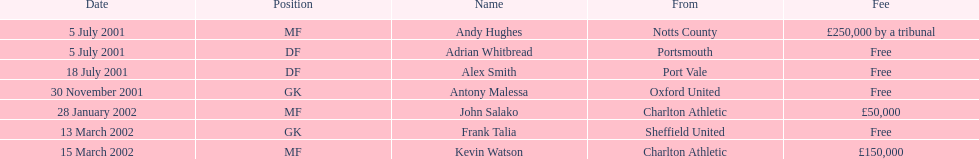What is the overall count of free charges? 4. 